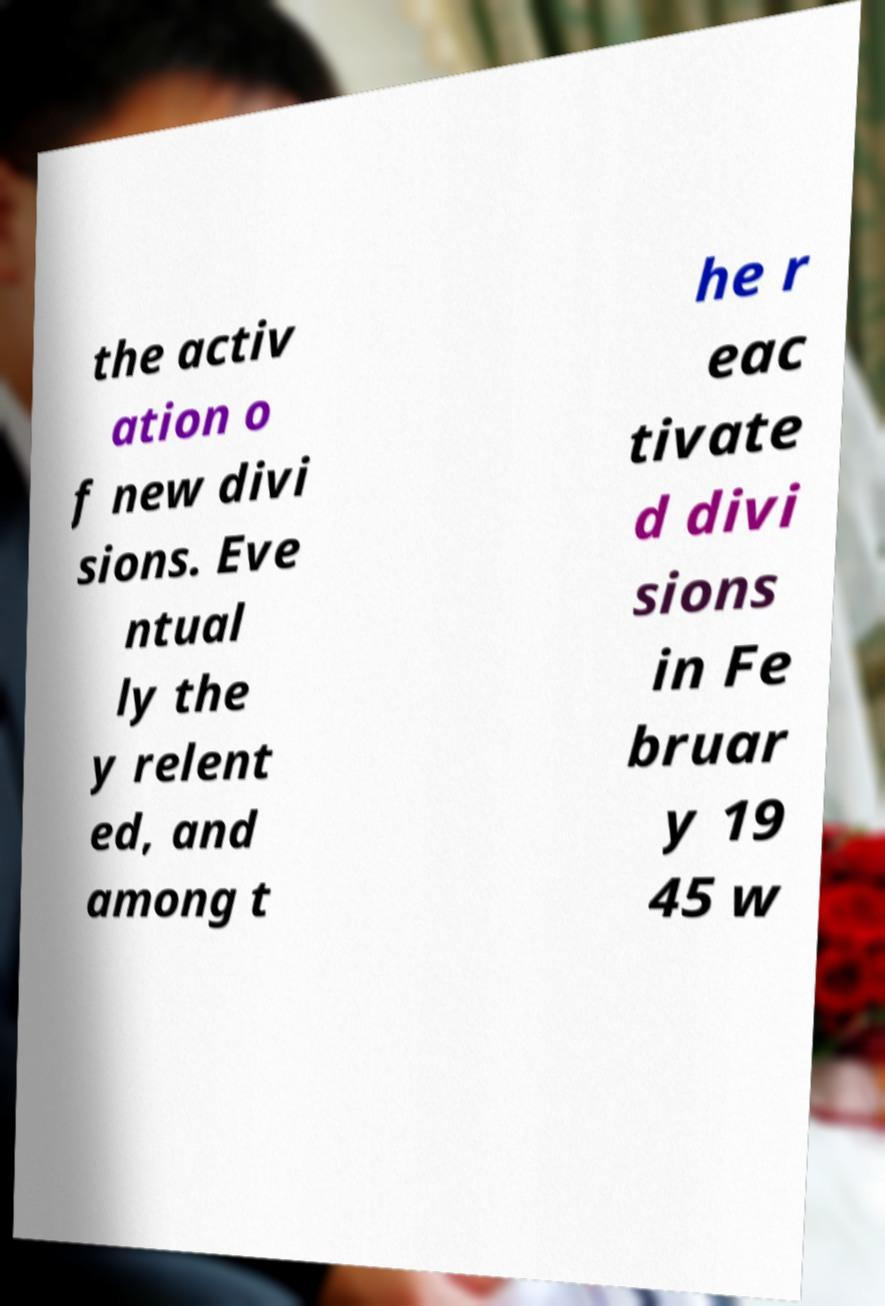Can you read and provide the text displayed in the image?This photo seems to have some interesting text. Can you extract and type it out for me? the activ ation o f new divi sions. Eve ntual ly the y relent ed, and among t he r eac tivate d divi sions in Fe bruar y 19 45 w 